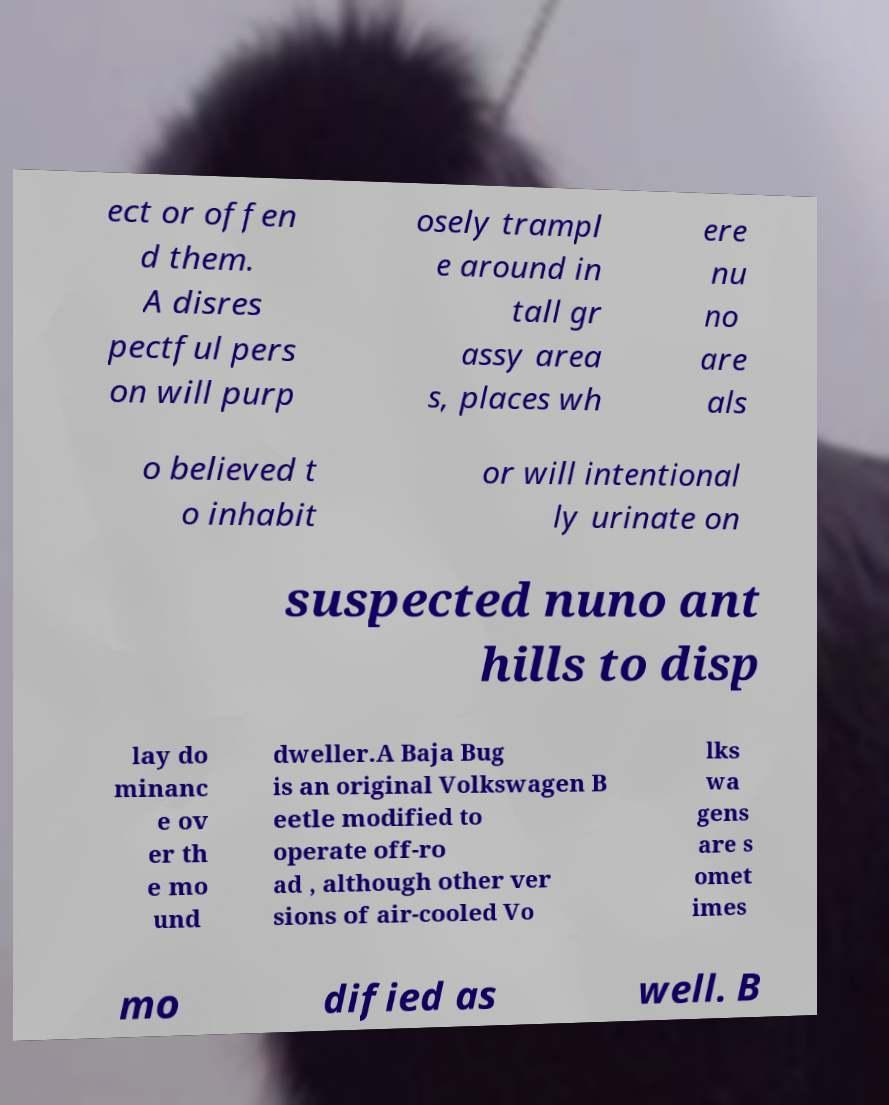Could you assist in decoding the text presented in this image and type it out clearly? ect or offen d them. A disres pectful pers on will purp osely trampl e around in tall gr assy area s, places wh ere nu no are als o believed t o inhabit or will intentional ly urinate on suspected nuno ant hills to disp lay do minanc e ov er th e mo und dweller.A Baja Bug is an original Volkswagen B eetle modified to operate off-ro ad , although other ver sions of air-cooled Vo lks wa gens are s omet imes mo dified as well. B 